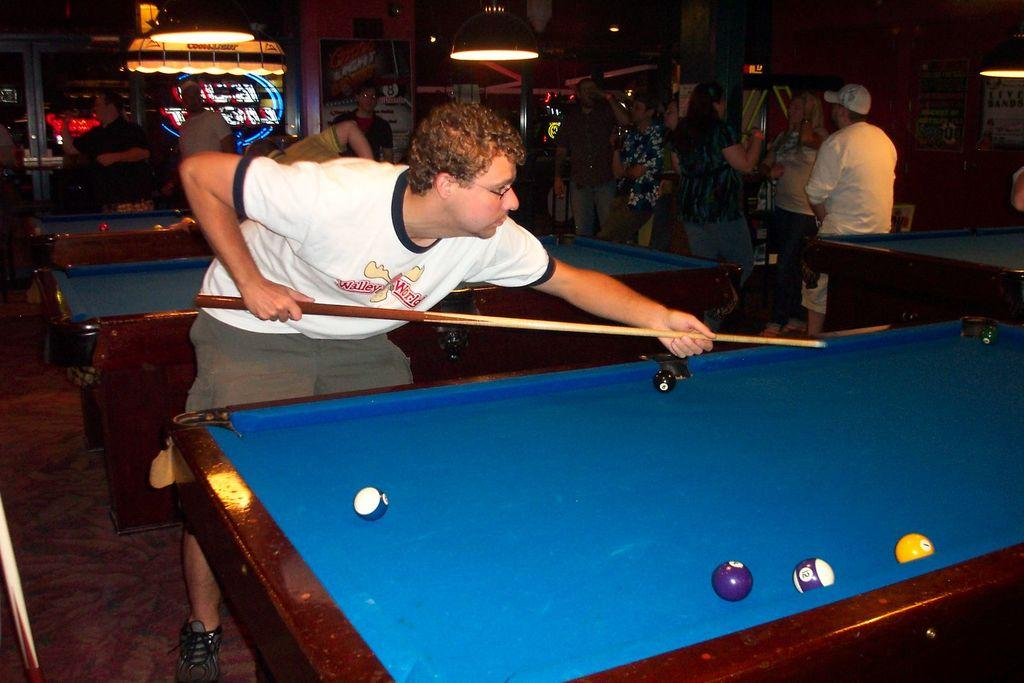What is the main subject of the image? The main subject of the image is a group of people. Can you describe one person in the group? There is a man with a white t-shirt in the image. What is the man with the white t-shirt doing? The man with the white t-shirt is standing and playing a game. What can be seen at the top of the image? There are lights visible at the top of the image. What type of toothpaste is the man with the white t-shirt using in the image? There is no toothpaste present in the image; the man with the white t-shirt is playing a game. 